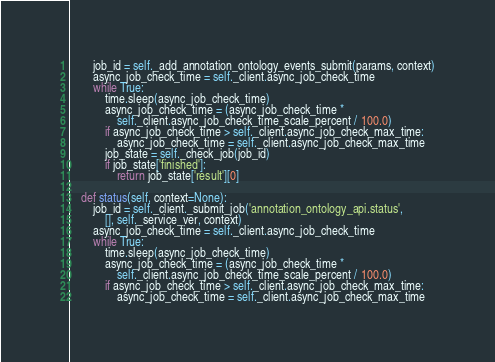<code> <loc_0><loc_0><loc_500><loc_500><_Python_>        job_id = self._add_annotation_ontology_events_submit(params, context)
        async_job_check_time = self._client.async_job_check_time
        while True:
            time.sleep(async_job_check_time)
            async_job_check_time = (async_job_check_time *
                self._client.async_job_check_time_scale_percent / 100.0)
            if async_job_check_time > self._client.async_job_check_max_time:
                async_job_check_time = self._client.async_job_check_max_time
            job_state = self._check_job(job_id)
            if job_state['finished']:
                return job_state['result'][0]

    def status(self, context=None):
        job_id = self._client._submit_job('annotation_ontology_api.status', 
            [], self._service_ver, context)
        async_job_check_time = self._client.async_job_check_time
        while True:
            time.sleep(async_job_check_time)
            async_job_check_time = (async_job_check_time *
                self._client.async_job_check_time_scale_percent / 100.0)
            if async_job_check_time > self._client.async_job_check_max_time:
                async_job_check_time = self._client.async_job_check_max_time</code> 